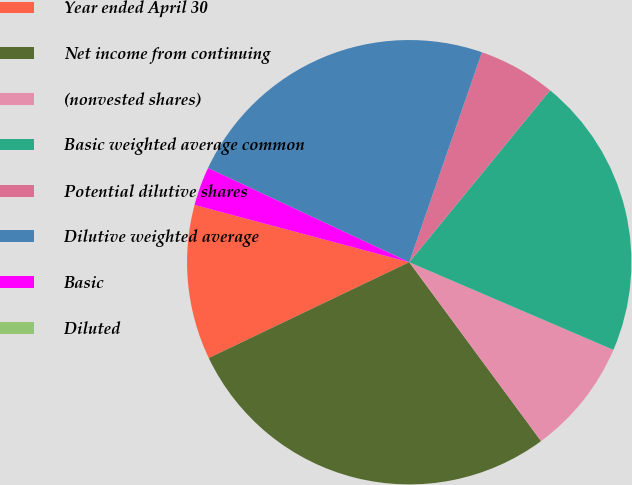Convert chart to OTSL. <chart><loc_0><loc_0><loc_500><loc_500><pie_chart><fcel>Year ended April 30<fcel>Net income from continuing<fcel>(nonvested shares)<fcel>Basic weighted average common<fcel>Potential dilutive shares<fcel>Dilutive weighted average<fcel>Basic<fcel>Diluted<nl><fcel>11.25%<fcel>28.01%<fcel>8.44%<fcel>20.53%<fcel>5.62%<fcel>23.34%<fcel>2.81%<fcel>0.0%<nl></chart> 